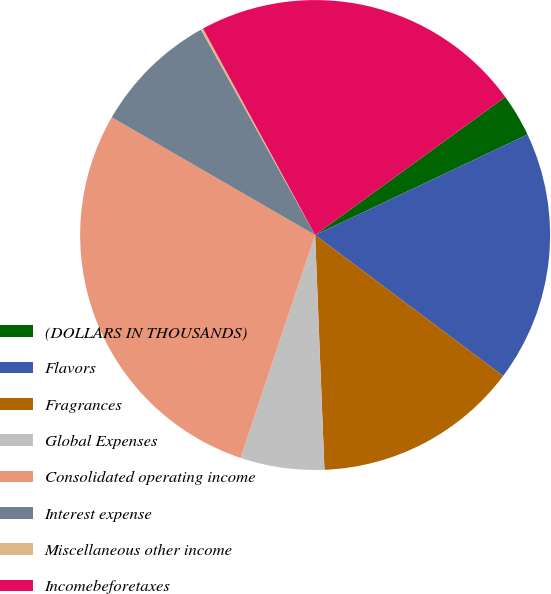<chart> <loc_0><loc_0><loc_500><loc_500><pie_chart><fcel>(DOLLARS IN THOUSANDS)<fcel>Flavors<fcel>Fragrances<fcel>Global Expenses<fcel>Consolidated operating income<fcel>Interest expense<fcel>Miscellaneous other income<fcel>Incomebeforetaxes<nl><fcel>2.96%<fcel>17.27%<fcel>14.13%<fcel>5.77%<fcel>28.21%<fcel>8.57%<fcel>0.16%<fcel>22.92%<nl></chart> 